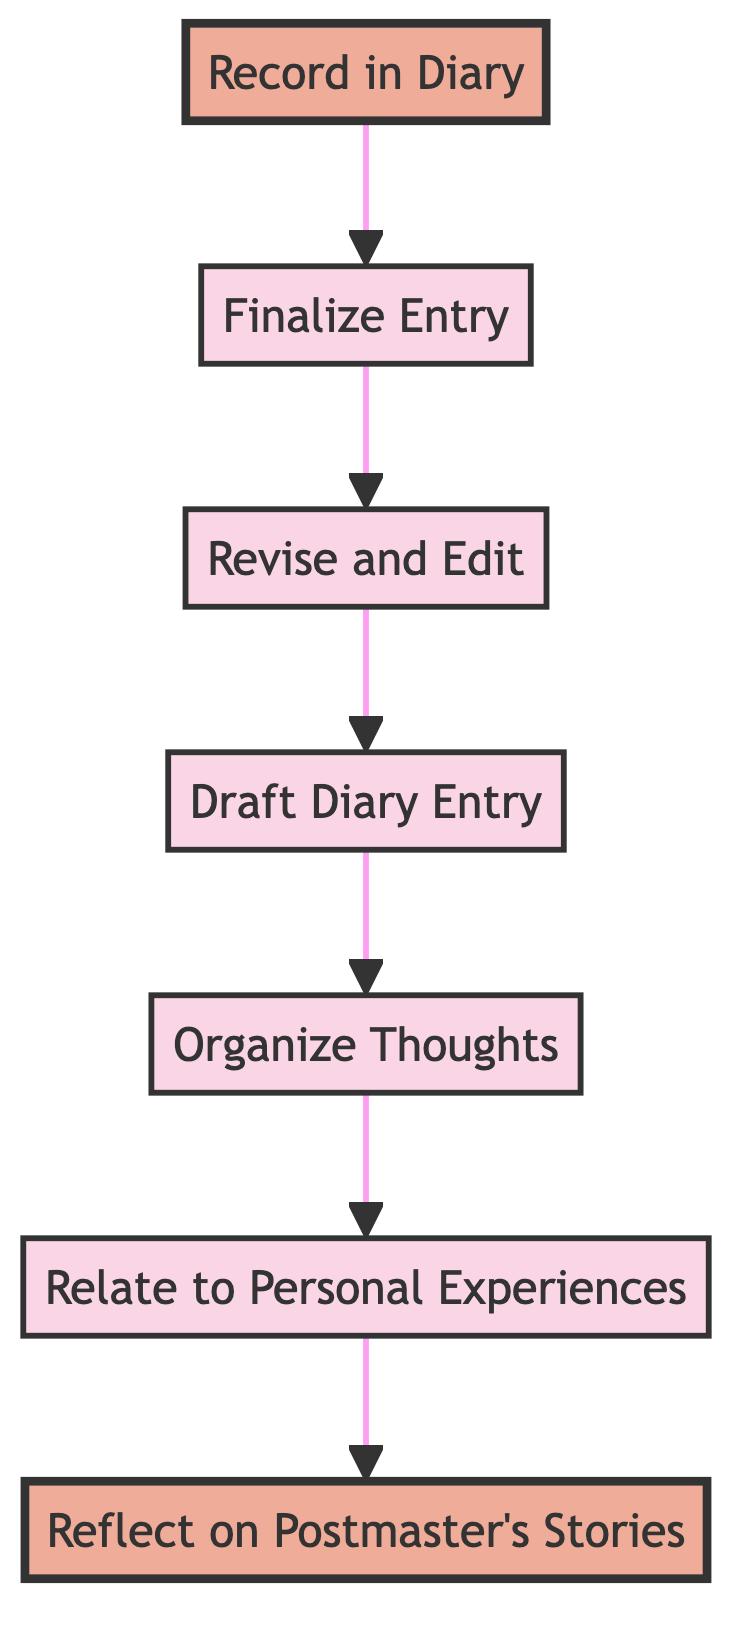What is the first step in the flowchart? The flowchart depicts a process that starts from the bottom, and the first step mentioned is "Reflect on Postmaster's Stories." By following the arrows upward, the flow begins with this node.
Answer: Reflect on Postmaster's Stories How many total steps are in the flowchart? By counting the nodes from the bottom to the top, there are seven distinct steps: "Reflect on Postmaster's Stories," "Relate to Personal Experiences," "Organize Thoughts," "Draft Diary Entry," "Revise and Edit," "Finalize Entry," and "Record in Diary." This gives a total of seven steps.
Answer: 7 What is the final step in the diagram? As we observe the flow from the bottom to the top, the last step, or the final node on the diagram, is "Record in Diary." This indicates the conclusion of the process.
Answer: Record in Diary Which two steps are highlighted in the flowchart? The flowchart highlights both "Record in Diary" and "Reflect on Postmaster's Stories," as indicated by the specific coloring and formatting designated in the diagram.
Answer: Record in Diary, Reflect on Postmaster's Stories What step follows after "Revise and Edit"? Analyzing the flow of the diagram, "Revise and Edit" is followed directly by "Finalize Entry," which is the next step in the upward process.
Answer: Finalize Entry Which step comes before "Organize Thoughts"? The step preceding "Organize Thoughts" in the sequence is "Relate to Personal Experiences." By following the direction of the flow, this can easily be identified.
Answer: Relate to Personal Experiences What progression leads from personal experiences to diary entry? The progression starts with "Reflect on Postmaster's Stories," which leads to "Relate to Personal Experiences." This step then leads to "Organize Thoughts," and after that "Draft Diary Entry," creating a pathway from experiences to the diary entry.
Answer: Reflect on Postmaster's Stories → Relate to Personal Experiences → Organize Thoughts → Draft Diary Entry Which step is directly above "Draft Diary Entry"? By examining the flowchart, the node located directly above "Draft Diary Entry" is "Revise and Edit," indicating the next stage after drafting.
Answer: Revise and Edit 